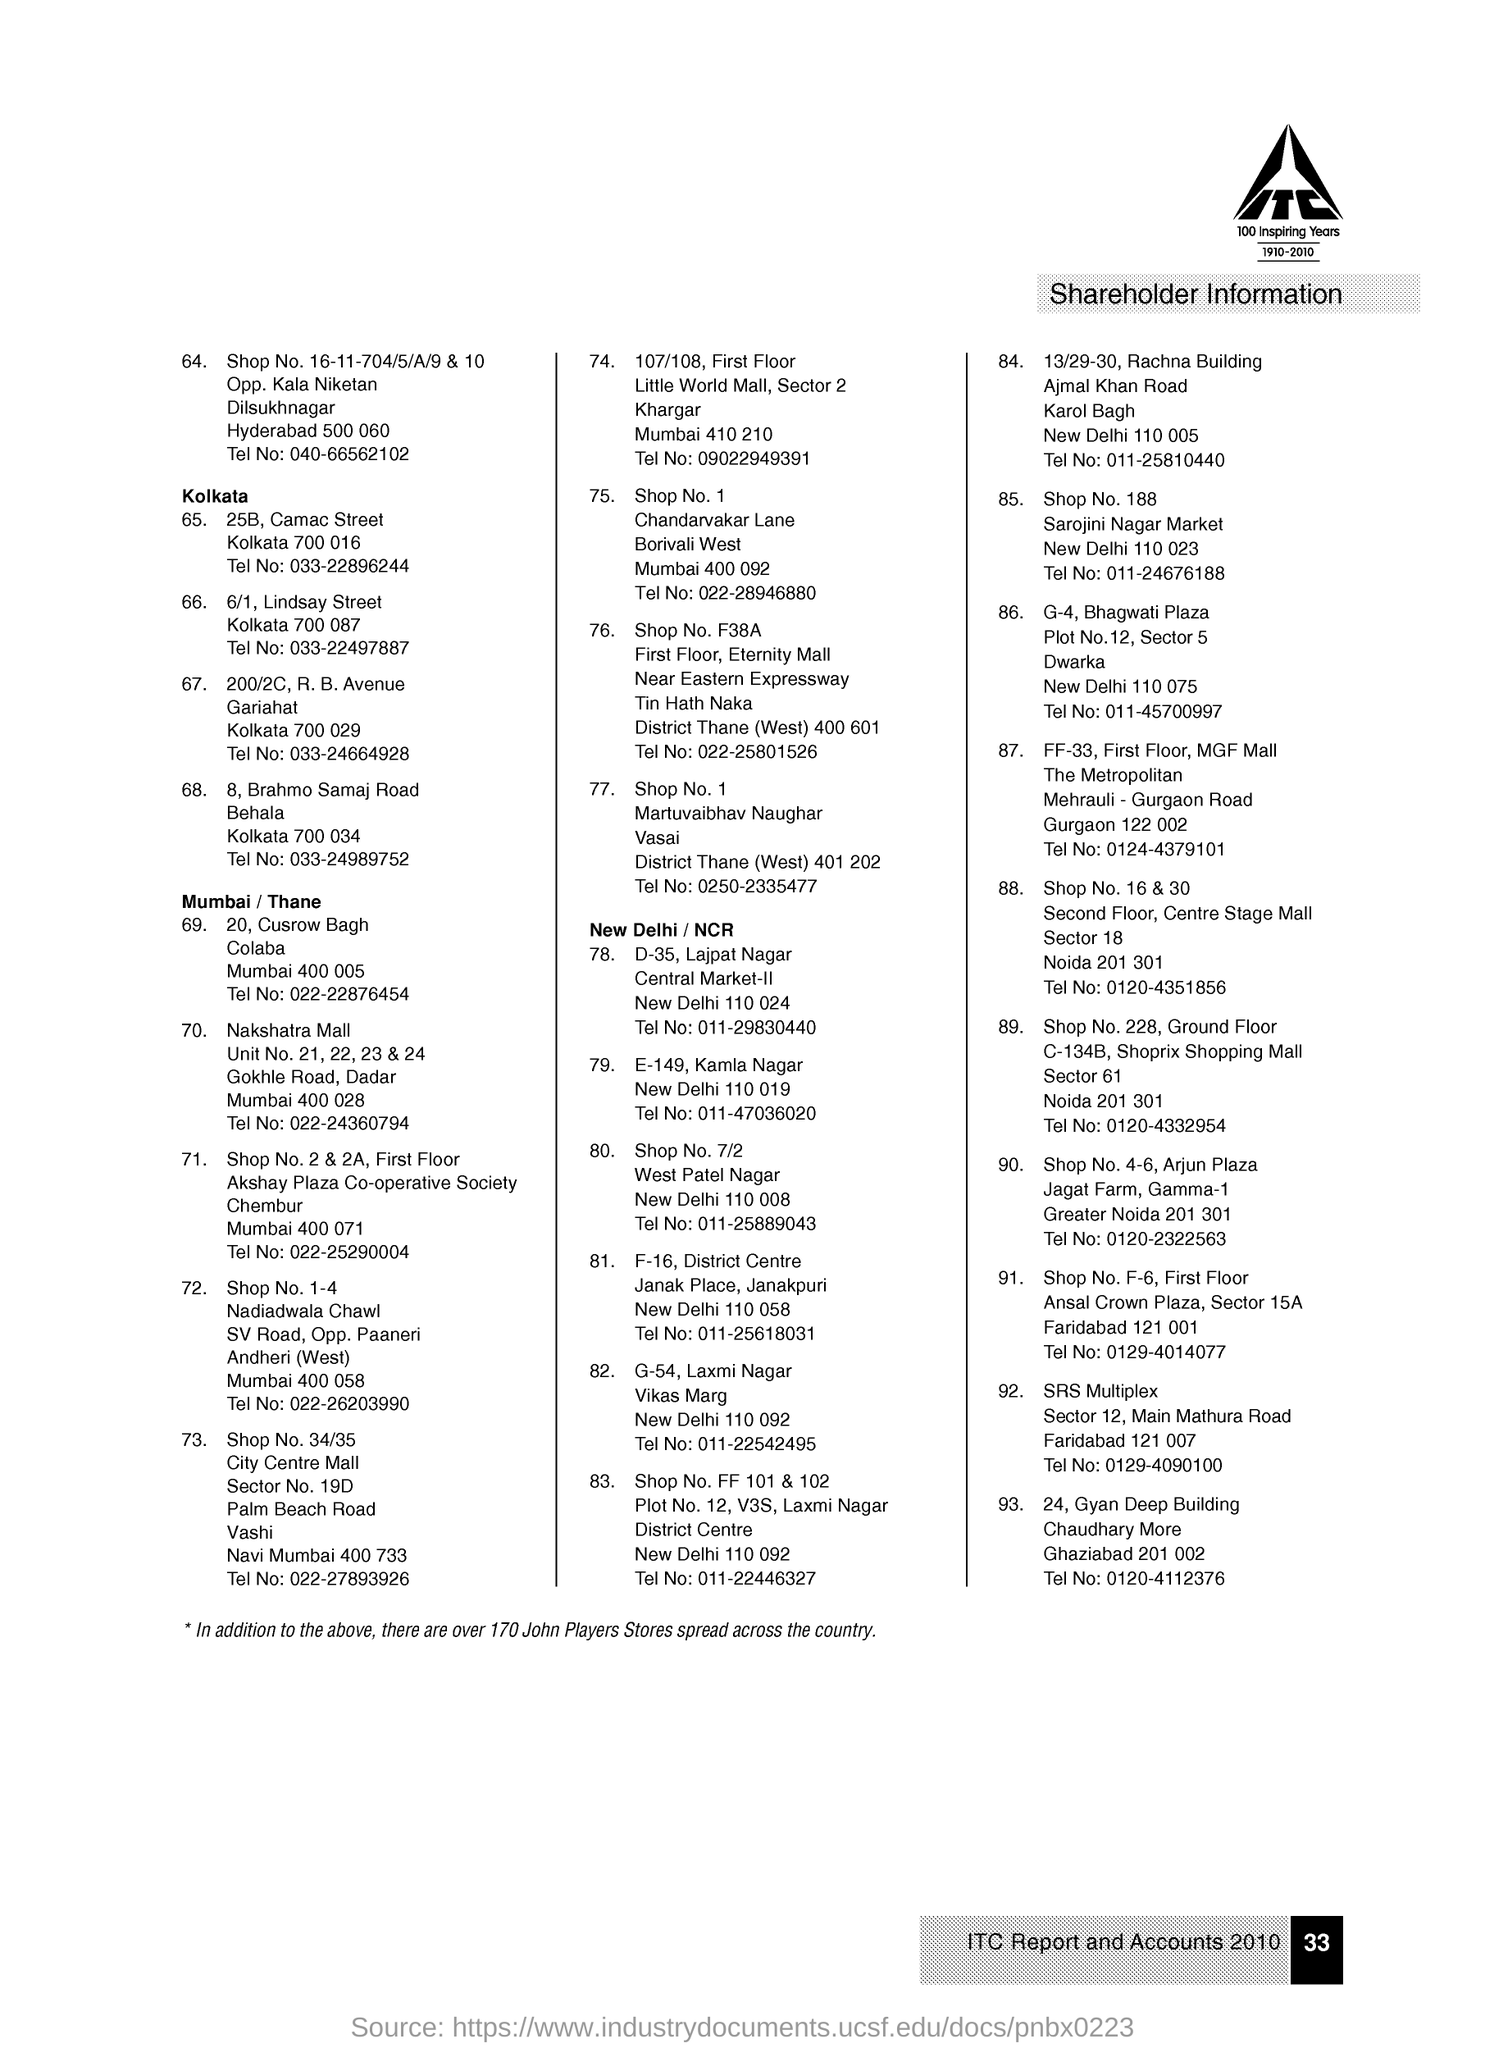What is written within the logo, given at the right top corner of the page?
Make the answer very short. ITC. From which year to which year is mentioned under the company logo?
Keep it short and to the point. 1910-2010. What "Information" is given in this page?
Make the answer very short. Shareholder Information. What is the serial number given to the first address?
Provide a succinct answer. 64. What is the telephone number given in serial number "69." address?
Make the answer very short. 022-22876454. From which city maximum number of shareholder's information is given?
Your response must be concise. New Delhi/ NCR. What is the serial number given to the last address?
Your answer should be very brief. 93. 